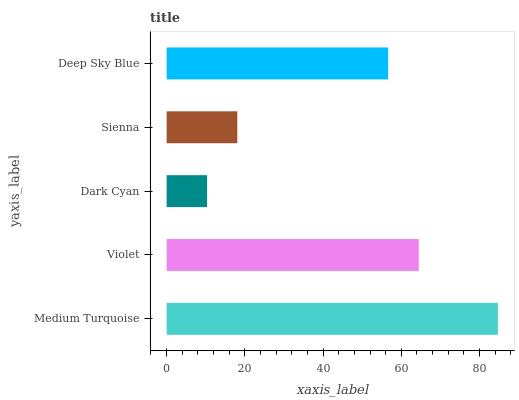Is Dark Cyan the minimum?
Answer yes or no. Yes. Is Medium Turquoise the maximum?
Answer yes or no. Yes. Is Violet the minimum?
Answer yes or no. No. Is Violet the maximum?
Answer yes or no. No. Is Medium Turquoise greater than Violet?
Answer yes or no. Yes. Is Violet less than Medium Turquoise?
Answer yes or no. Yes. Is Violet greater than Medium Turquoise?
Answer yes or no. No. Is Medium Turquoise less than Violet?
Answer yes or no. No. Is Deep Sky Blue the high median?
Answer yes or no. Yes. Is Deep Sky Blue the low median?
Answer yes or no. Yes. Is Medium Turquoise the high median?
Answer yes or no. No. Is Medium Turquoise the low median?
Answer yes or no. No. 